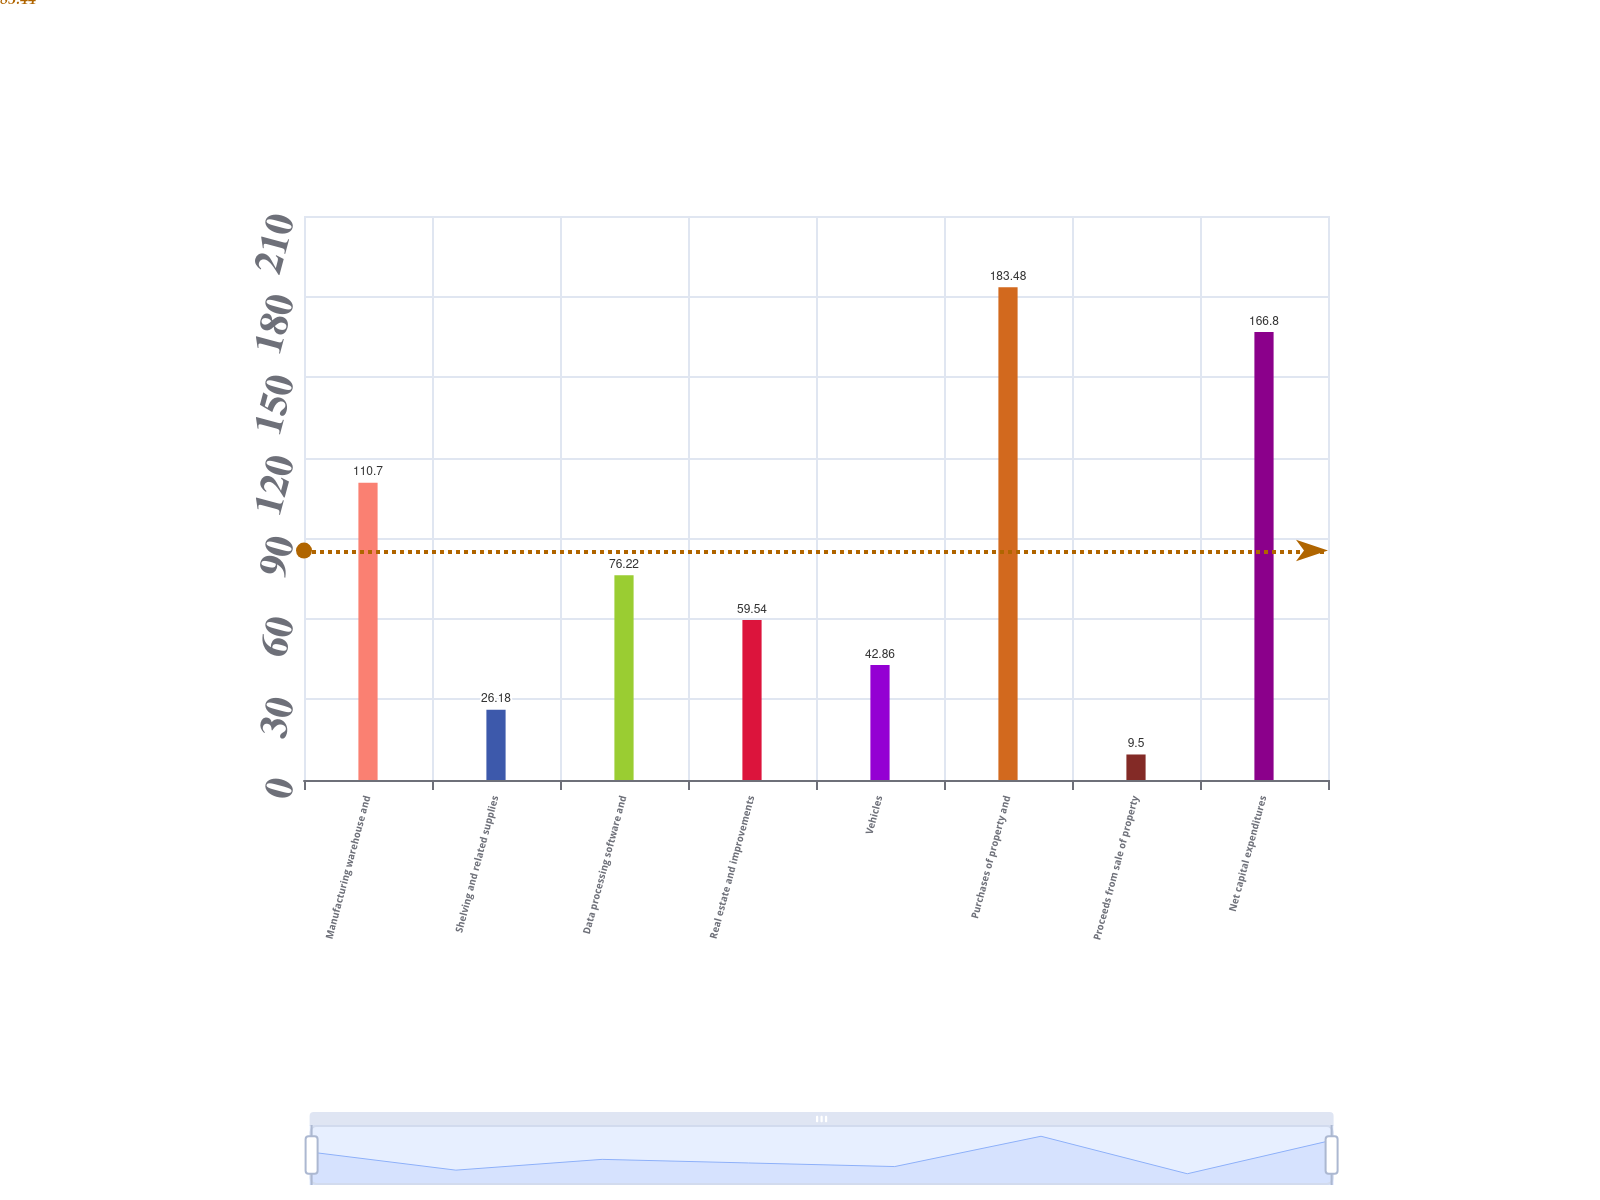Convert chart to OTSL. <chart><loc_0><loc_0><loc_500><loc_500><bar_chart><fcel>Manufacturing warehouse and<fcel>Shelving and related supplies<fcel>Data processing software and<fcel>Real estate and improvements<fcel>Vehicles<fcel>Purchases of property and<fcel>Proceeds from sale of property<fcel>Net capital expenditures<nl><fcel>110.7<fcel>26.18<fcel>76.22<fcel>59.54<fcel>42.86<fcel>183.48<fcel>9.5<fcel>166.8<nl></chart> 